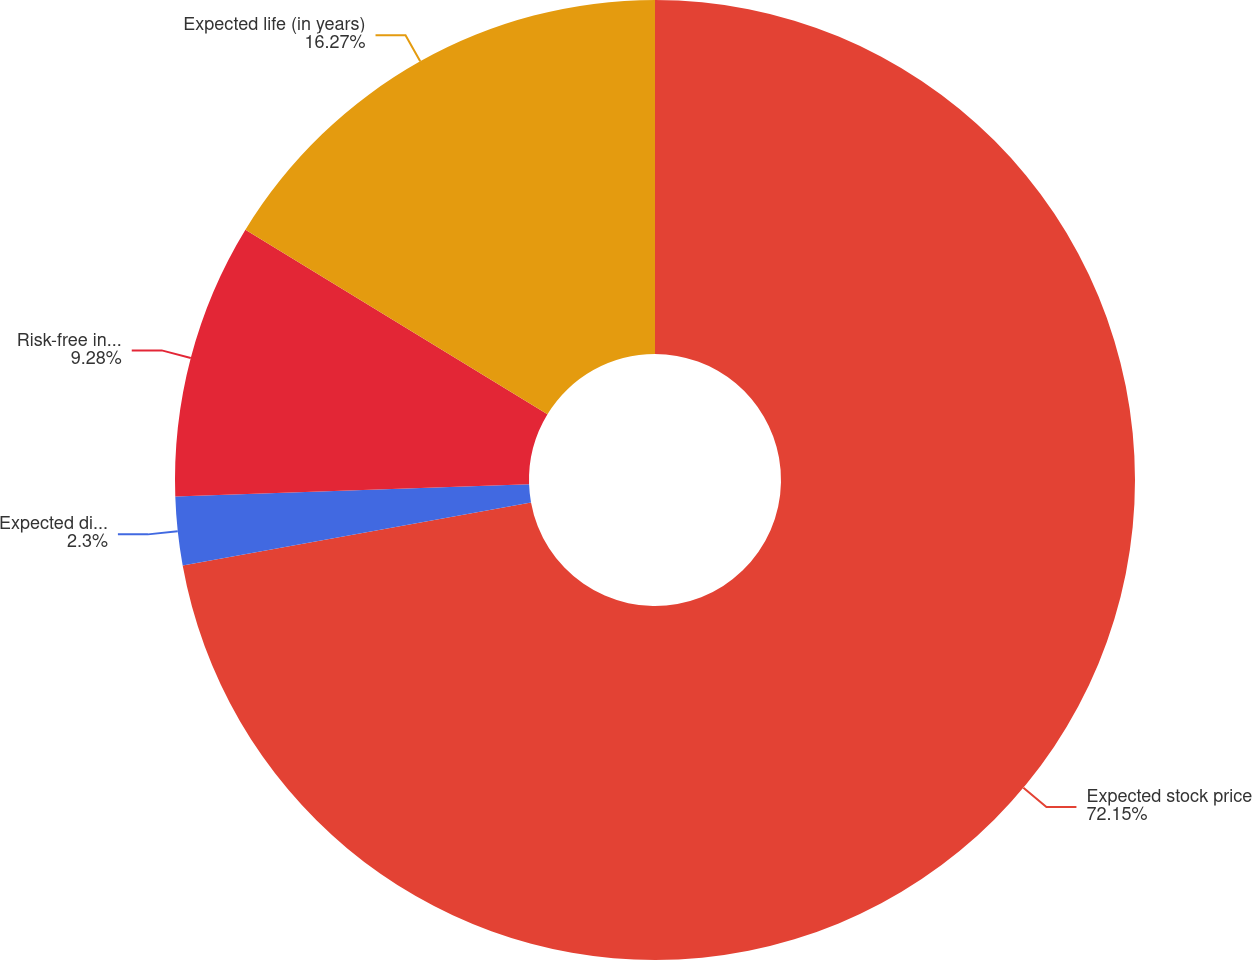Convert chart. <chart><loc_0><loc_0><loc_500><loc_500><pie_chart><fcel>Expected stock price<fcel>Expected dividend yield<fcel>Risk-free interest rate<fcel>Expected life (in years)<nl><fcel>72.15%<fcel>2.3%<fcel>9.28%<fcel>16.27%<nl></chart> 